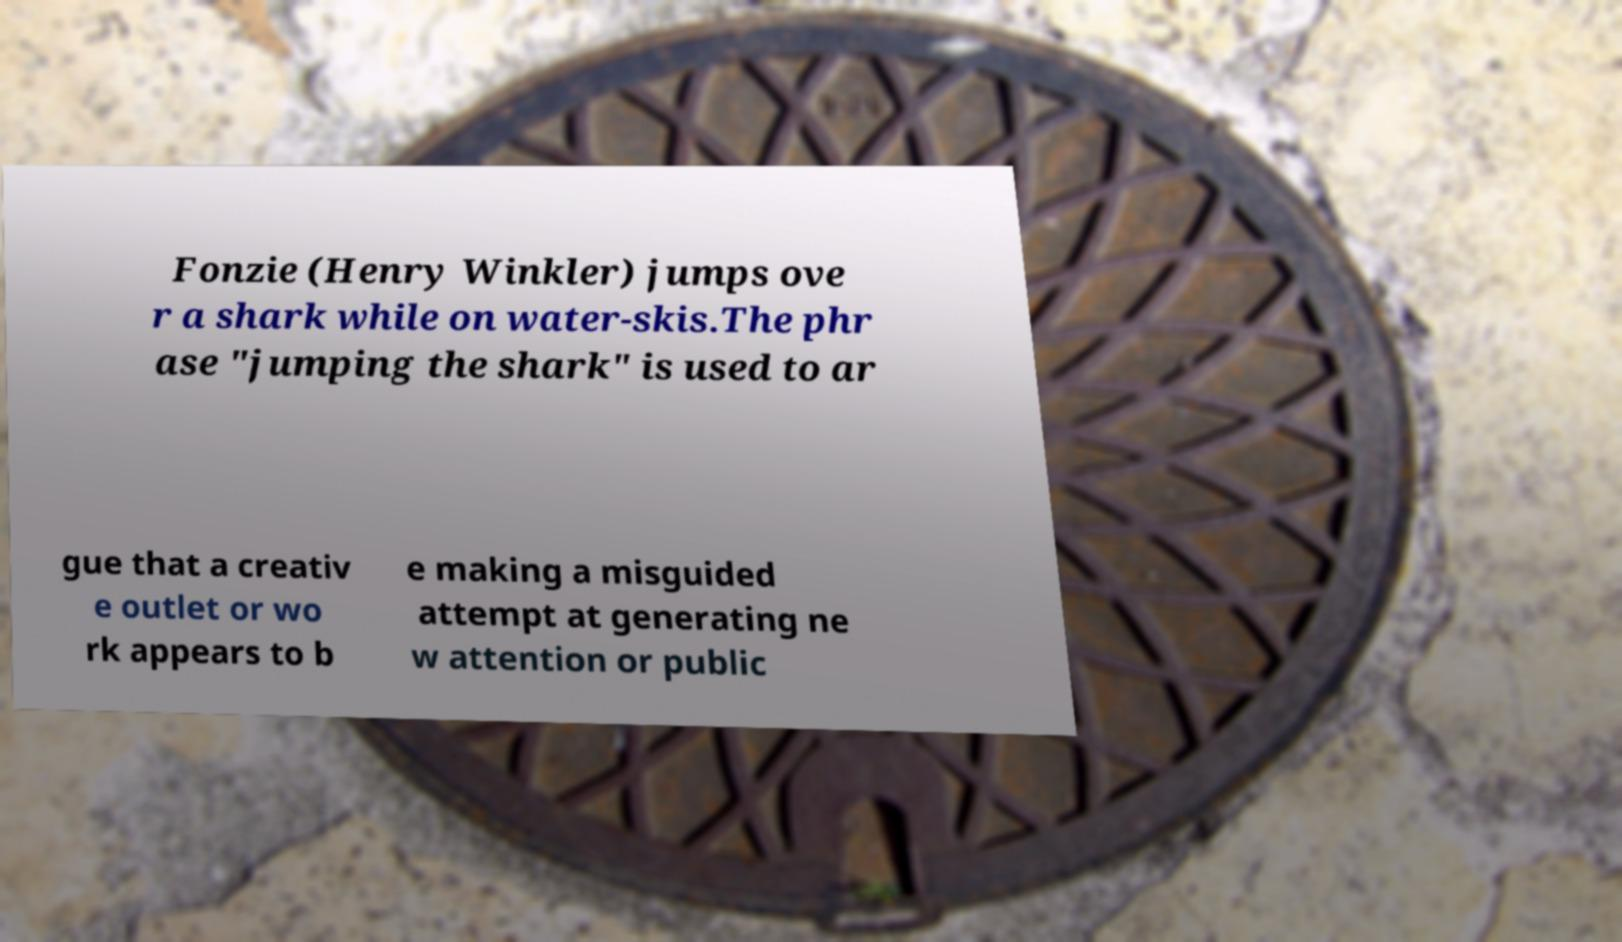Can you read and provide the text displayed in the image?This photo seems to have some interesting text. Can you extract and type it out for me? Fonzie (Henry Winkler) jumps ove r a shark while on water-skis.The phr ase "jumping the shark" is used to ar gue that a creativ e outlet or wo rk appears to b e making a misguided attempt at generating ne w attention or public 